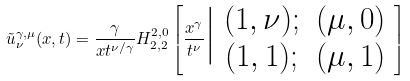<formula> <loc_0><loc_0><loc_500><loc_500>\tilde { u } ^ { \gamma , \mu } _ { \nu } ( x , t ) = \frac { \gamma } { x t ^ { \nu / \gamma } } H ^ { 2 , 0 } _ { 2 , 2 } \left [ \frac { x ^ { \gamma } } { t ^ { \nu } } \Big | \begin{array} { c c } ( 1 , \nu ) ; & ( \mu , 0 ) \\ ( 1 , 1 ) ; & ( \mu , 1 ) \end{array} \right ]</formula> 